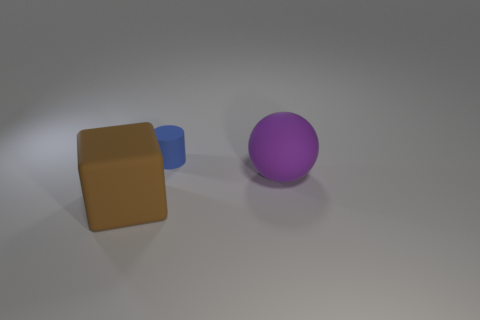Can you tell me the colors of the objects in the image? Certainly! In the image, there are three objects: a large brown block, a medium-sized blue block, and a purple sphere. 